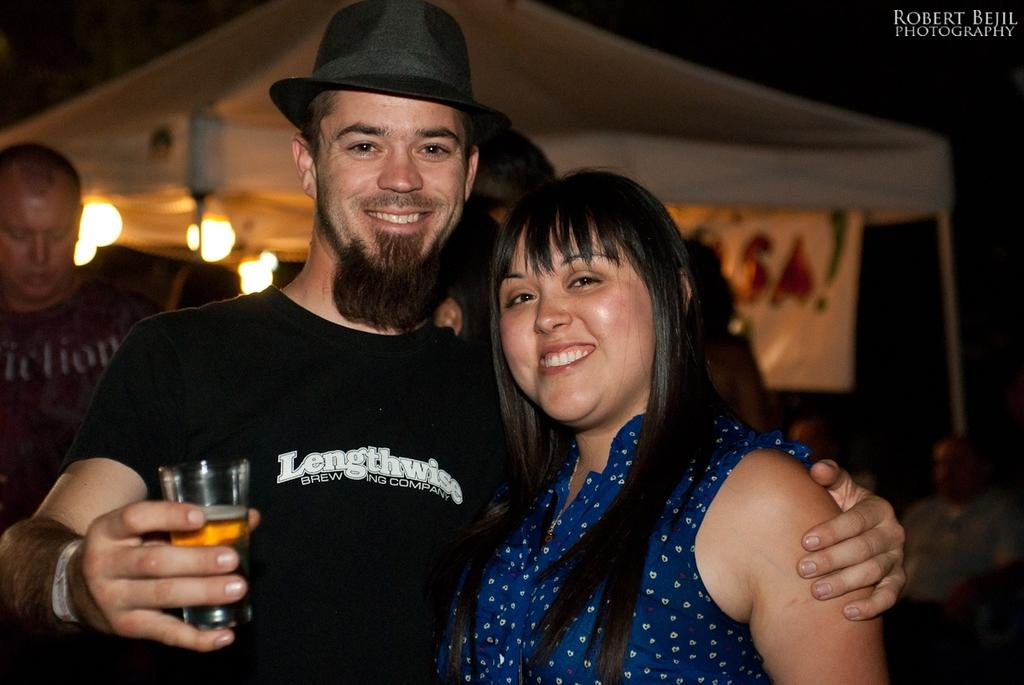Who is present in the image? There is a man and a woman in the image. What is the man holding in the image? The man is holding a glass in the image. What can be seen in the background of the image? There is a tent and lights visible in the background of the image. What is the man wearing on his head? The man is wearing a hat in the image. What expressions do the man and woman have in the image? Both the man and woman are smiling in the image. How many letters can be seen on the man's toes in the image? There are no letters visible on the man's toes in the image. What type of bag is the woman carrying in the image? There is no bag visible in the image. 